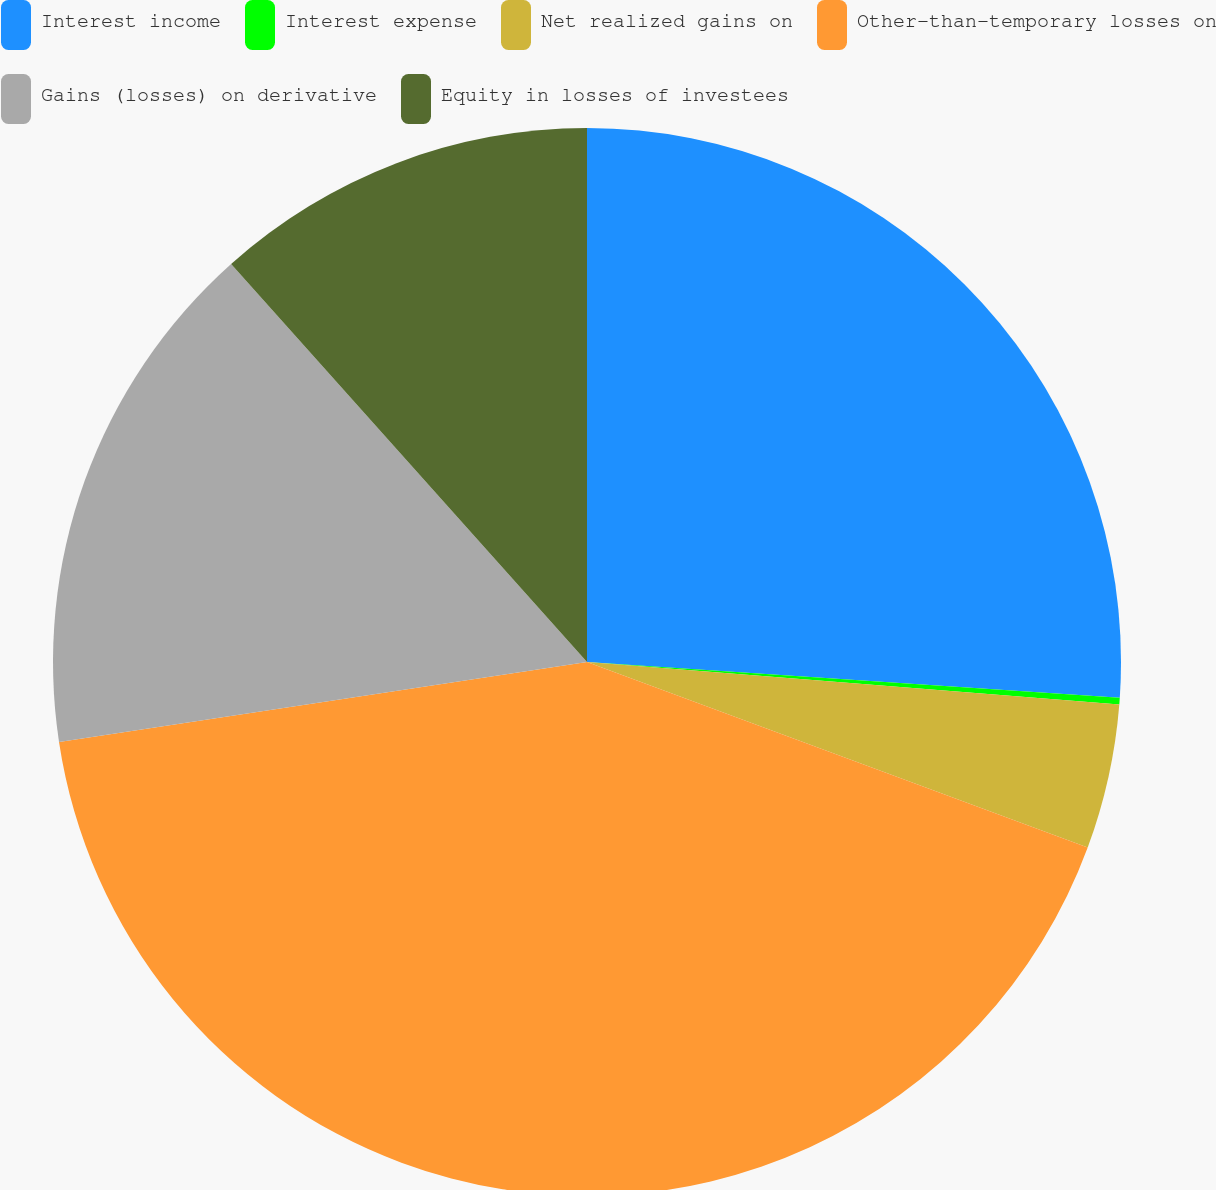Convert chart to OTSL. <chart><loc_0><loc_0><loc_500><loc_500><pie_chart><fcel>Interest income<fcel>Interest expense<fcel>Net realized gains on<fcel>Other-than-temporary losses on<fcel>Gains (losses) on derivative<fcel>Equity in losses of investees<nl><fcel>26.07%<fcel>0.2%<fcel>4.38%<fcel>41.96%<fcel>15.78%<fcel>11.61%<nl></chart> 